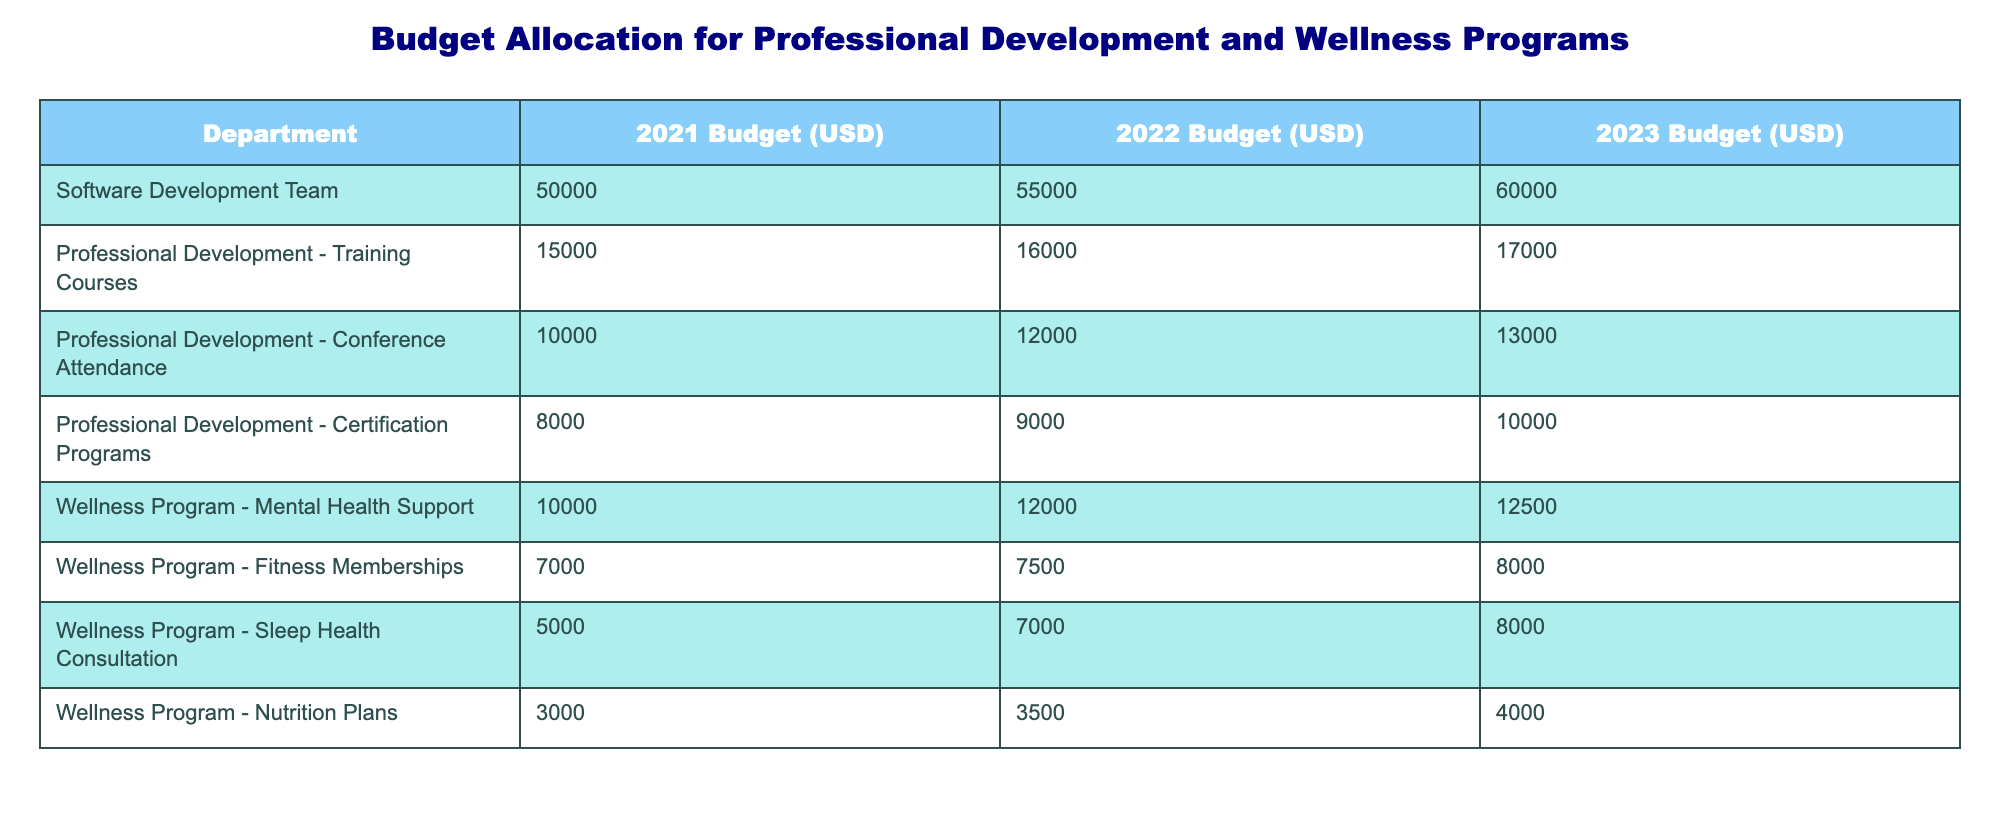What is the total budget allocated for the Software Development Team in 2023? Looking at the table under the "2023 Budget (USD)" column for the "Software Development Team", the value is 60000.
Answer: 60000 What is the increase in the budget for Professional Development - Training Courses from 2021 to 2023? The budget for Professional Development - Training Courses was 15000 in 2021 and 17000 in 2023. The increase is calculated as 17000 - 15000 = 2000.
Answer: 2000 Is the budget for Wellness Program - Sleep Health Consultation higher in 2023 than in 2022? In 2023, the budget for Sleep Health Consultation is 8000, while in 2022 it was 7000. Since 8000 is greater than 7000, the statement is true.
Answer: Yes What is the average budget allocated for the Professional Development programs (Training Courses, Conference Attendance, Certification Programs) in 2023? The budgets for these programs in 2023 are 17000, 13000, and 10000 respectively. First, sum them: 17000 + 13000 + 10000 = 40000. Then, divide by the number of programs (3): 40000 / 3 = 13333.33.
Answer: 13333.33 Which department received the highest budget in 2022? The only department listed is the Software Development Team, which received a budget of 55000 in 2022. Checking other categories like Professional Development and Wellness Programs shows the highest allocation is also from the Software Development Team; thus, it is the highest.
Answer: Yes What is the difference in the budget for Wellness Program - Nutrition Plans between 2021 and 2023? For Wellness Program - Nutrition Plans, the budget was 3000 in 2021 and increased to 4000 in 2023. The difference is calculated as 4000 - 3000 = 1000.
Answer: 1000 What is the total budget for all Wellness Programs in 2023? Summing the budgets for Wellness Programs in 2023 gives: Mental Health Support (12500) + Fitness Memberships (8000) + Sleep Health Consultation (8000) + Nutrition Plans (4000) = 40000.
Answer: 40000 Did the budget for Professional Development - Conference Attendance decrease at any point from 2021 to 2023? Looking at the budget figures, Professional Development - Conference Attendance was 10000 in 2021, increased to 12000 in 2022, and then to 13000 in 2023. There was no decrease during this period.
Answer: No What is the total budget allocated for all categories in 2021? Summing all categories for 2021, we get: Software Development Team (50000) + Training Courses (15000) + Conference Attendance (10000) + Certification Programs (8000) + Mental Health Support (10000) + Fitness Memberships (7000) + Sleep Health Consultation (5000) + Nutrition Plans (3000) = 106000.
Answer: 106000 